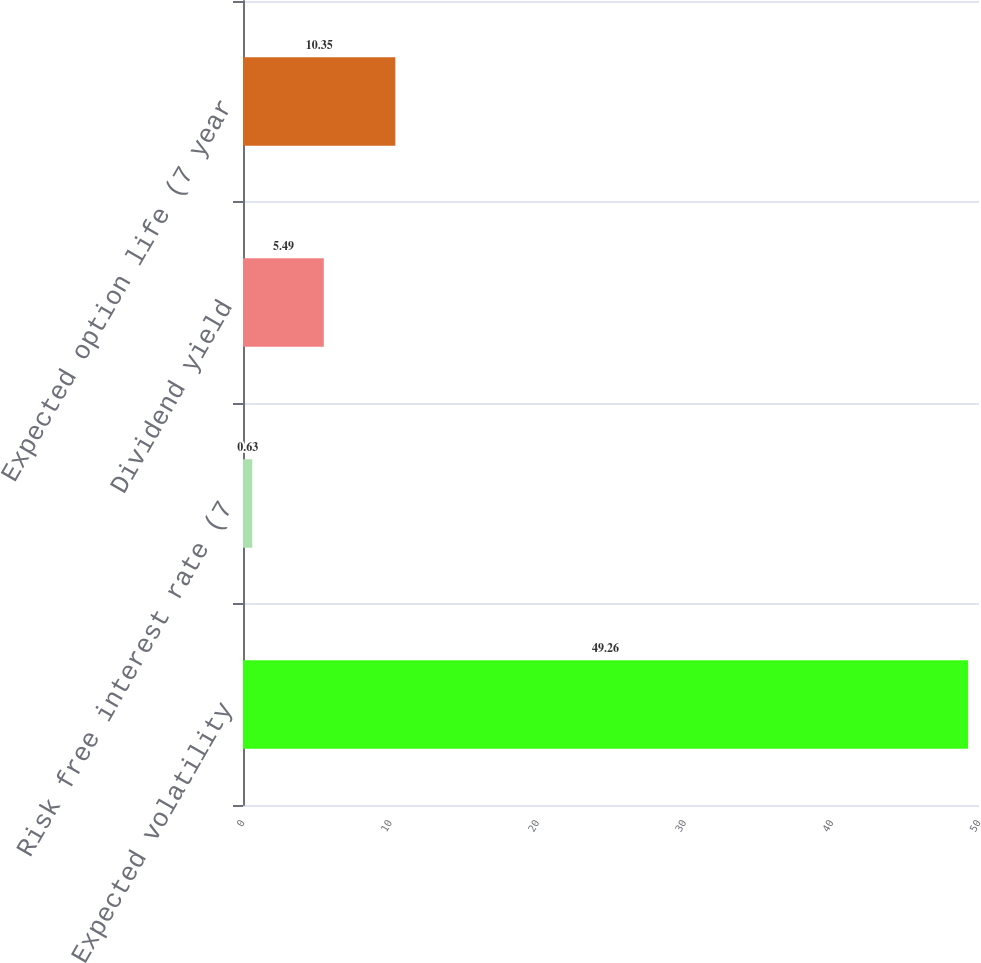Convert chart to OTSL. <chart><loc_0><loc_0><loc_500><loc_500><bar_chart><fcel>Expected volatility<fcel>Risk free interest rate (7<fcel>Dividend yield<fcel>Expected option life (7 year<nl><fcel>49.26<fcel>0.63<fcel>5.49<fcel>10.35<nl></chart> 